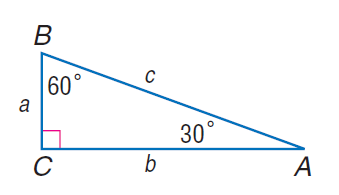Answer the mathemtical geometry problem and directly provide the correct option letter.
Question: If b = 18, find c.
Choices: A: 9 B: 6 \sqrt { 3 } C: 18 D: 12 \sqrt { 3 } D 